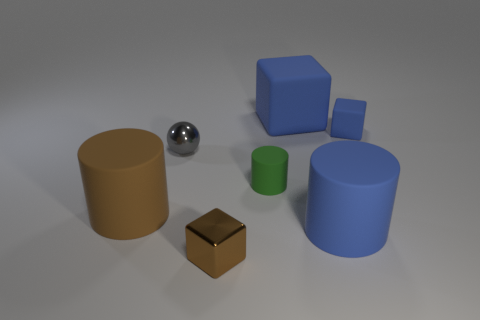Add 2 tiny green things. How many objects exist? 9 Subtract all blocks. How many objects are left? 4 Subtract 0 cyan balls. How many objects are left? 7 Subtract all small shiny blocks. Subtract all matte blocks. How many objects are left? 4 Add 1 small gray metal spheres. How many small gray metal spheres are left? 2 Add 7 green matte cylinders. How many green matte cylinders exist? 8 